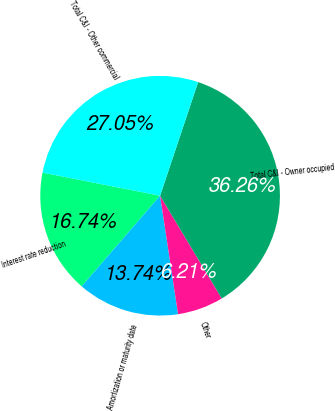<chart> <loc_0><loc_0><loc_500><loc_500><pie_chart><fcel>Interest rate reduction<fcel>Amortization or maturity date<fcel>Other<fcel>Total C&I - Owner occupied<fcel>Total C&I - Other commercial<nl><fcel>16.74%<fcel>13.74%<fcel>6.21%<fcel>36.26%<fcel>27.05%<nl></chart> 